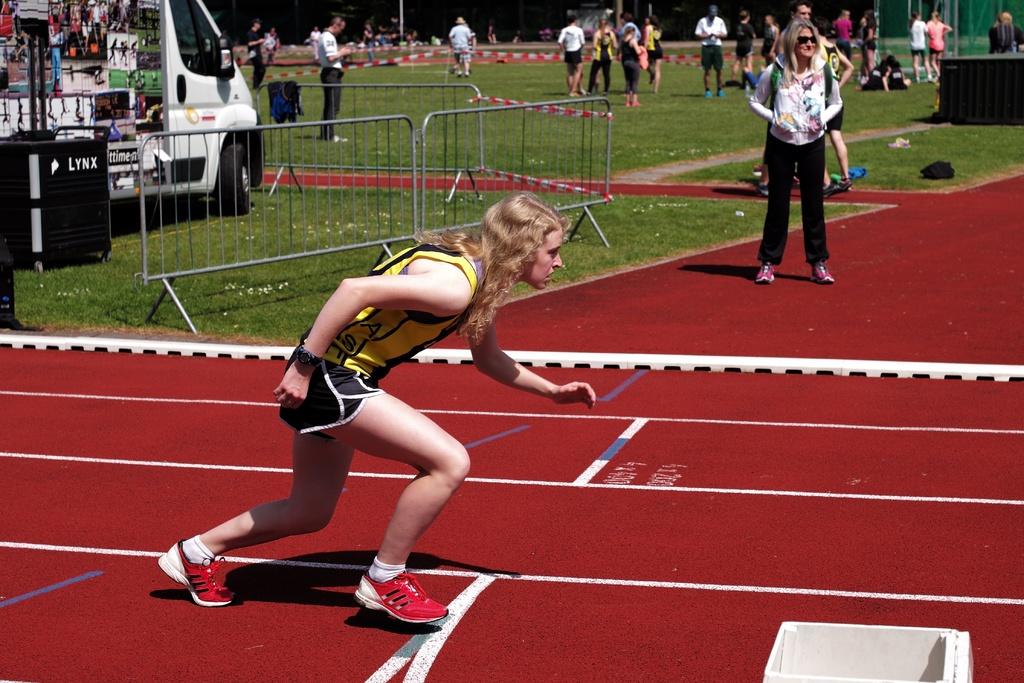What is written on the black box?
Your response must be concise. Lynx. 